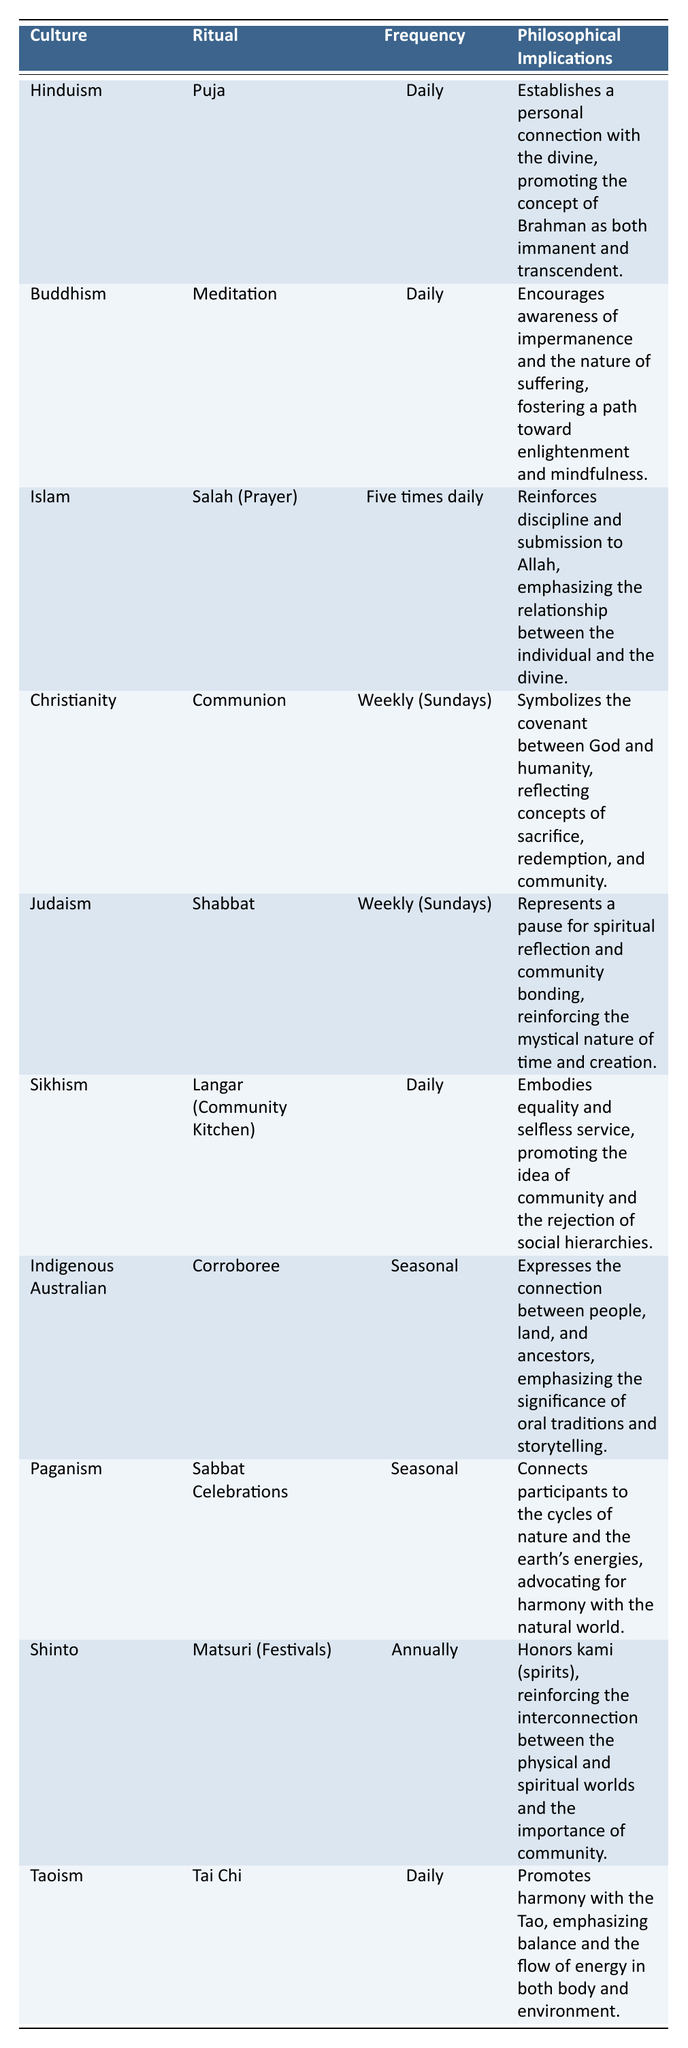What is the ritual performed in Christianity? The table shows that the ritual performed in Christianity is Communion.
Answer: Communion How often is the Langar ritual conducted in Sikhism? According to the table, the Langar ritual is conducted daily in Sikhism.
Answer: Daily Is the frequency of rituals in Buddhism and Hinduism the same? Yes, both Buddhism (Meditation) and Hinduism (Puja) have daily rituals according to the table.
Answer: Yes Which ritual emphasizes the cycles of nature and is performed seasonally? The Sabbat Celebrations in Paganism emphasizes the cycles of nature and is performed seasonally.
Answer: Sabbat Celebrations Which culture has daily rituals that promote equality and selfless service? Sikhism practices the Langar ritual daily, promoting equality and selfless service.
Answer: Sikhism How many cultures have a weekly ritual? According to the table, there are three cultures (Christianity, Judaism) that have weekly rituals.
Answer: Three What is the philosophical implication of the Shabbat ritual in Judaism? The Shabbat ritual symbolizes a pause for spiritual reflection and community bonding, reinforcing the mystical nature of time and creation.
Answer: Pause for reflection and bonding Which culture conducts its rituals the least frequently, and how often? Shinto conducts its Matsuri (Festivals) rituals annually, making it the least frequent.
Answer: Annually What is the relationship between the frequency of a ritual and its philosophical implication in Indigenous Australian culture? The Corroboree festival is seasonal and expresses a connection to land and ancestors, which implies that infrequency allows for deeper community and environmental reflection.
Answer: Seasonal festivals enhance connection Which cultures incorporate daily rituals in their practices? The cultures that incorporate daily rituals are Hinduism, Buddhism, Islam, Sikhism, and Taoism.
Answer: Five cultures If you compare the frequencies of rituals in Buddhism and Taoism, are they the same or different? Both Buddhism and Taoism rituals are performed daily, indicating they are the same in this regard.
Answer: Same What philosophical implication is emphasized by the Salah (Prayer) ritual in Islam? The Salah ritual reinforces discipline and submission to Allah, emphasizing the individual's relationship with the divine.
Answer: Discipline and submission How does the frequency of rituals differ between Indigenous Australian and Pagan cultures? Indigenous Australians perform Corroborees seasonally, while Paganism conducts Sabbat Celebrations seasonally as well, thus they differ from others but not from each other.
Answer: They are both seasonal 